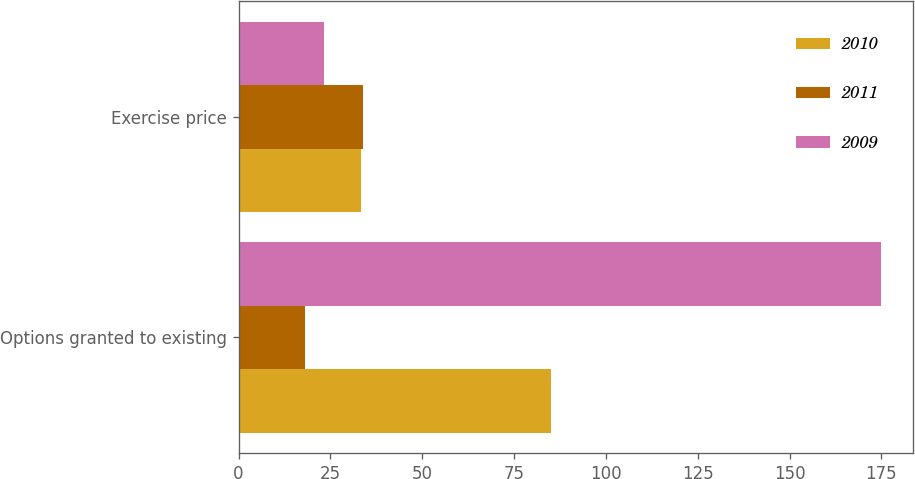Convert chart to OTSL. <chart><loc_0><loc_0><loc_500><loc_500><stacked_bar_chart><ecel><fcel>Options granted to existing<fcel>Exercise price<nl><fcel>2010<fcel>85<fcel>33.23<nl><fcel>2011<fcel>18<fcel>33.82<nl><fcel>2009<fcel>175<fcel>23.28<nl></chart> 